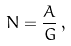<formula> <loc_0><loc_0><loc_500><loc_500>N = \frac { A } { G } \, ,</formula> 